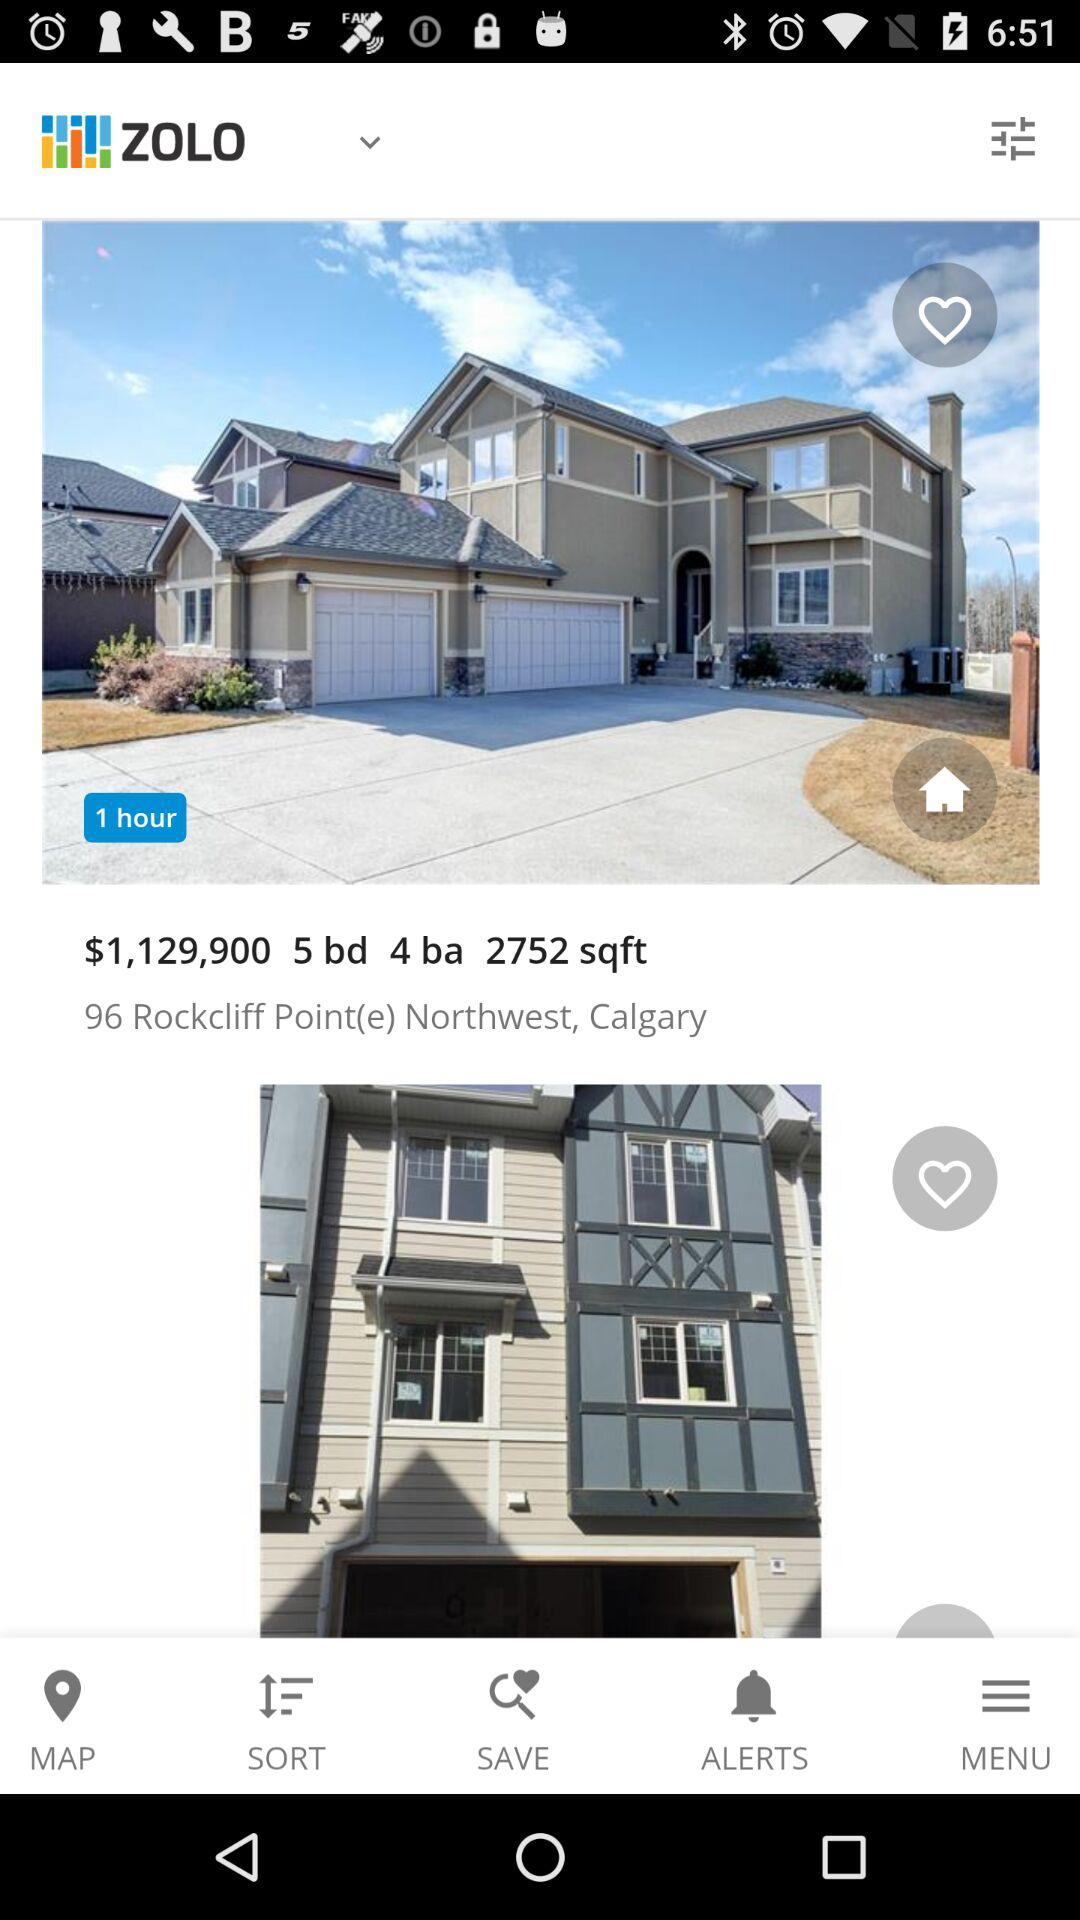What is the name of the application? The name of the application is "ZOLO". 